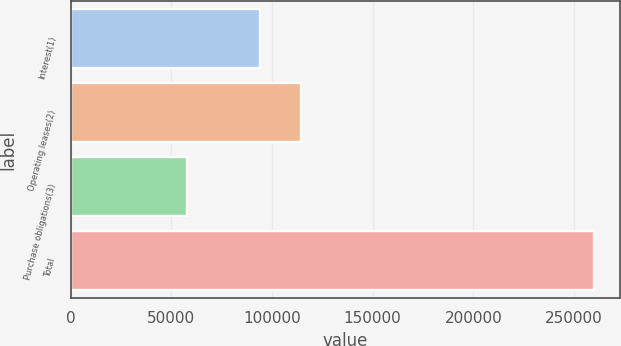<chart> <loc_0><loc_0><loc_500><loc_500><bar_chart><fcel>Interest(1)<fcel>Operating leases(2)<fcel>Purchase obligations(3)<fcel>Total<nl><fcel>94200<fcel>114408<fcel>57821<fcel>259899<nl></chart> 